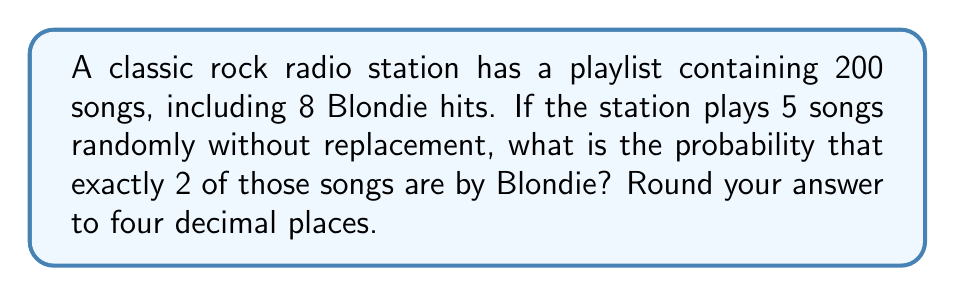Provide a solution to this math problem. Let's approach this step-by-step using the hypergeometric distribution:

1) We have a population of 200 songs, of which 8 are Blondie songs.
2) We're selecting 5 songs without replacement.
3) We want the probability of selecting exactly 2 Blondie songs.

The probability is given by the hypergeometric distribution formula:

$$P(X=k) = \frac{\binom{K}{k}\binom{N-K}{n-k}}{\binom{N}{n}}$$

Where:
$N$ = total number of songs = 200
$K$ = number of Blondie songs = 8
$n$ = number of songs selected = 5
$k$ = number of Blondie songs we want = 2

Let's calculate each combination:

$$\binom{8}{2} = 28$$
$$\binom{192}{3} = 1,150,560$$
$$\binom{200}{5} = 2,535,650,040$$

Now, let's plug these into our formula:

$$P(X=2) = \frac{28 \cdot 1,150,560}{2,535,650,040} = \frac{32,215,680}{2,535,650,040} = 0.012705$$

Rounding to four decimal places: 0.0127
Answer: 0.0127 